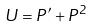Convert formula to latex. <formula><loc_0><loc_0><loc_500><loc_500>U = P ^ { \prime } + P ^ { 2 }</formula> 